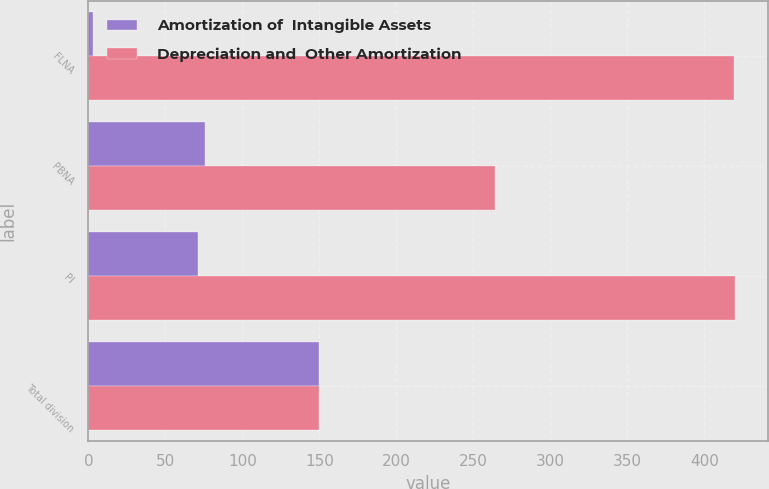Convert chart. <chart><loc_0><loc_0><loc_500><loc_500><stacked_bar_chart><ecel><fcel>FLNA<fcel>PBNA<fcel>PI<fcel>Total division<nl><fcel>Amortization of  Intangible Assets<fcel>3<fcel>76<fcel>71<fcel>150<nl><fcel>Depreciation and  Other Amortization<fcel>419<fcel>264<fcel>420<fcel>150<nl></chart> 